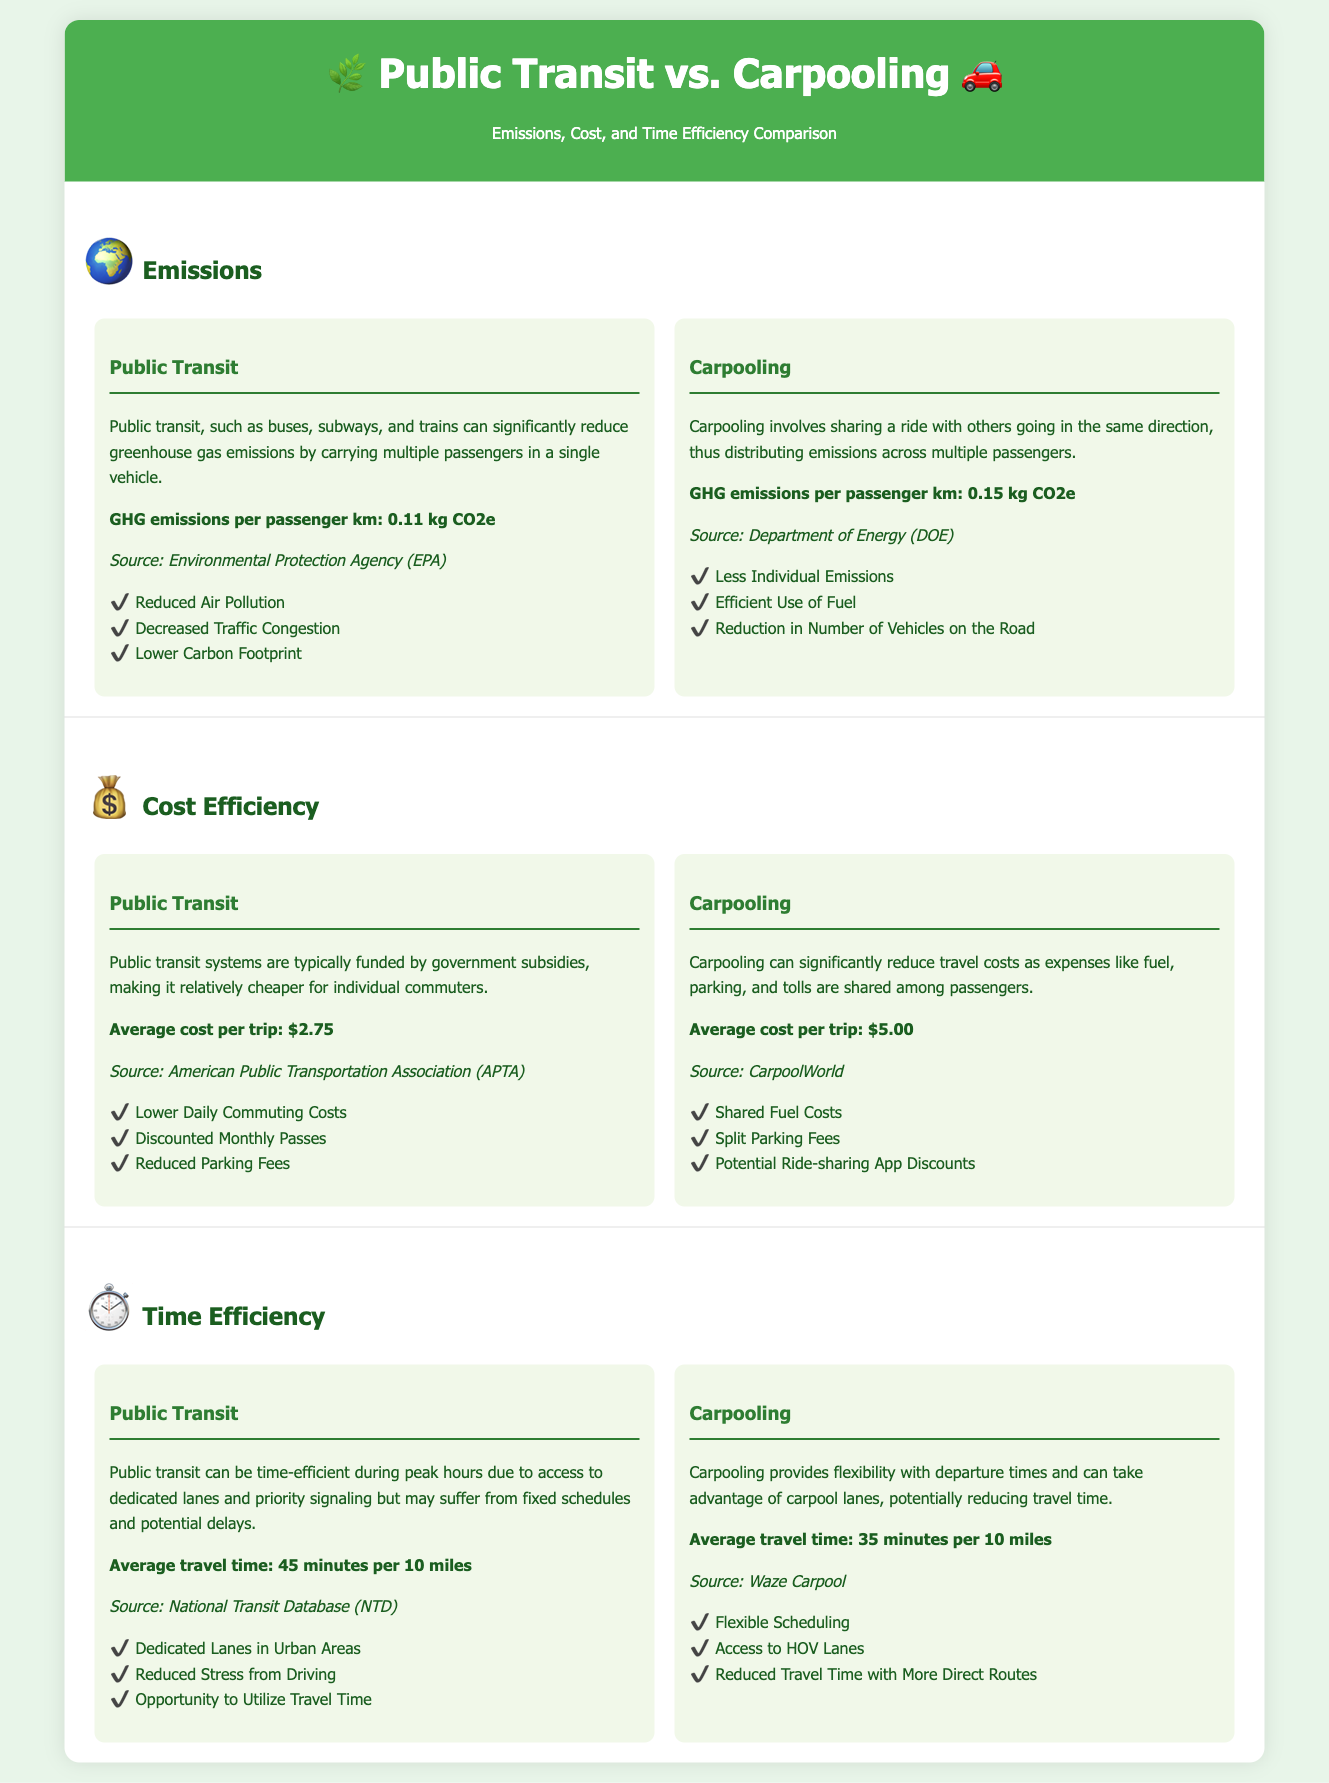What are the GHG emissions per passenger km for public transit? The document states that GHG emissions per passenger km for public transit is 0.11 kg CO2e.
Answer: 0.11 kg CO2e What is the average cost per trip for public transit? According to the document, the average cost per trip for public transit is $2.75.
Answer: $2.75 Which mode of transportation has a higher GHG emissions per passenger km? The GHG emissions for carpooling is higher than for public transit, as it is mentioned as 0.15 kg CO2e.
Answer: Carpooling What is the average travel time for carpooling? The document indicates that the average travel time for carpooling is 35 minutes per 10 miles.
Answer: 35 minutes What is one benefit of public transit mentioned in the document? The document highlights benefits of public transit, such as "Reduced Air Pollution."
Answer: Reduced Air Pollution Which transportation option allows for flexible scheduling according to the document? The benefits listed for carpooling mention "Flexible Scheduling."
Answer: Carpooling What is the average cost per trip for carpooling? The average cost per trip for carpooling is stated to be $5.00 in the document.
Answer: $5.00 How much faster is carpooling compared to public transit for the same distance? Carpooling has an average travel time of 35 minutes while public transit has 45 minutes, making it 10 minutes faster.
Answer: 10 minutes What is the total average travel time for both options combined? To find the combined average travel time, take the sum of each average: 45 minutes for public transit and 35 minutes for carpooling, which totals 80 minutes for 20 miles.
Answer: 80 minutes 